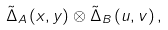<formula> <loc_0><loc_0><loc_500><loc_500>\tilde { \Delta } _ { A } \left ( x , y \right ) \otimes \tilde { \Delta } _ { B } \left ( u , v \right ) ,</formula> 